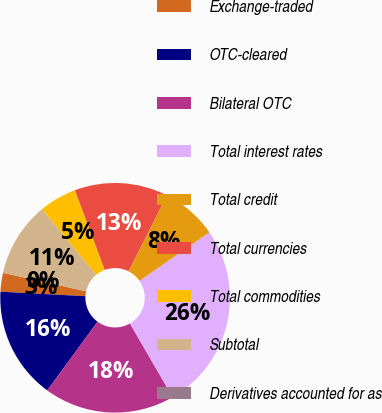<chart> <loc_0><loc_0><loc_500><loc_500><pie_chart><fcel>Exchange-traded<fcel>OTC-cleared<fcel>Bilateral OTC<fcel>Total interest rates<fcel>Total credit<fcel>Total currencies<fcel>Total commodities<fcel>Subtotal<fcel>Derivatives accounted for as<nl><fcel>2.64%<fcel>15.79%<fcel>18.42%<fcel>26.3%<fcel>7.9%<fcel>13.16%<fcel>5.27%<fcel>10.53%<fcel>0.01%<nl></chart> 